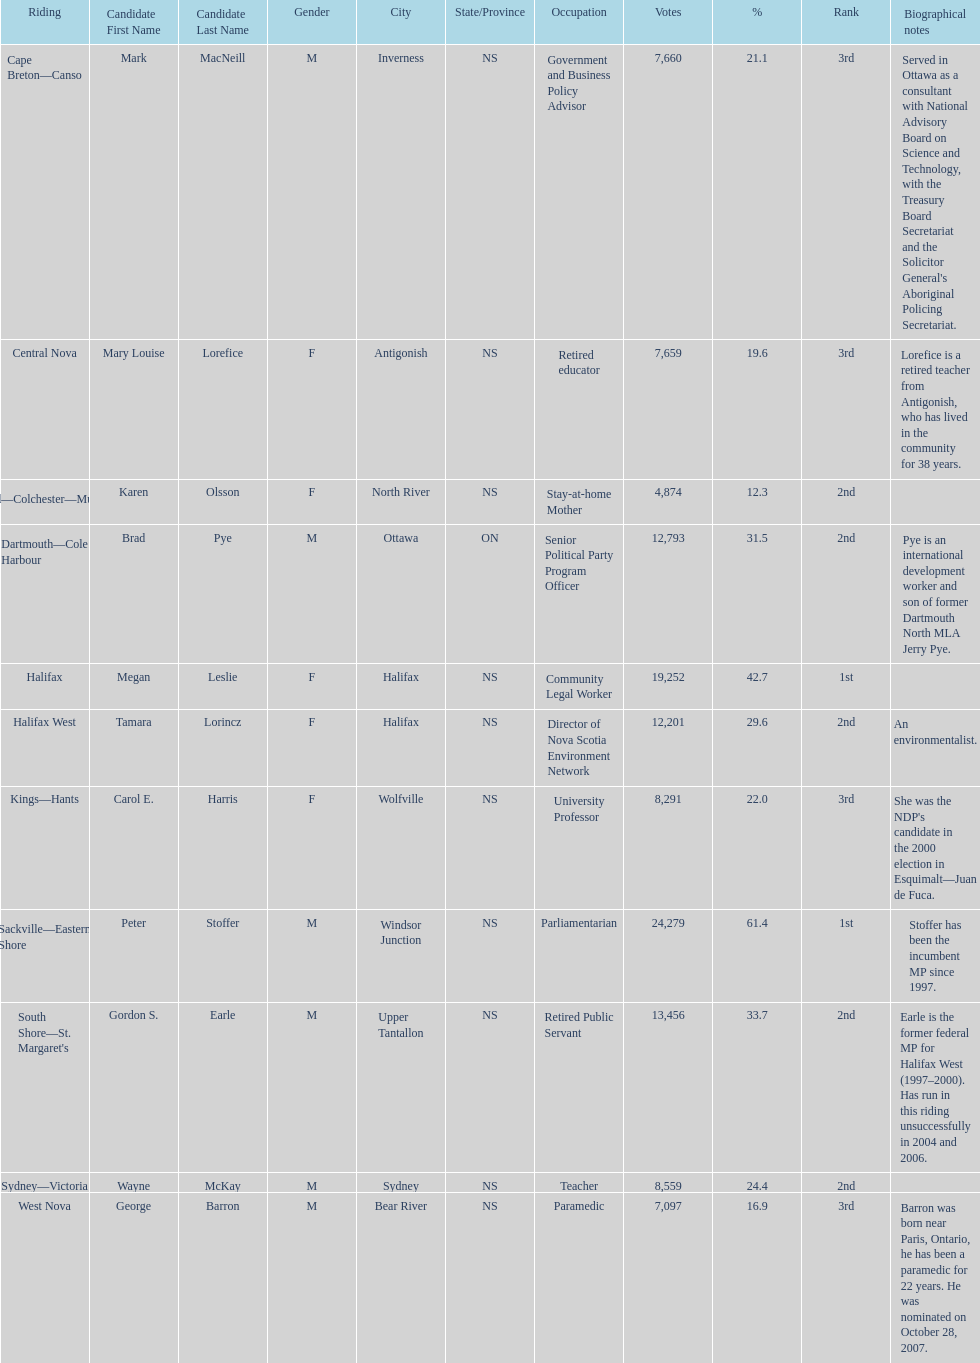Who received the least amount of votes? Karen Olsson. 